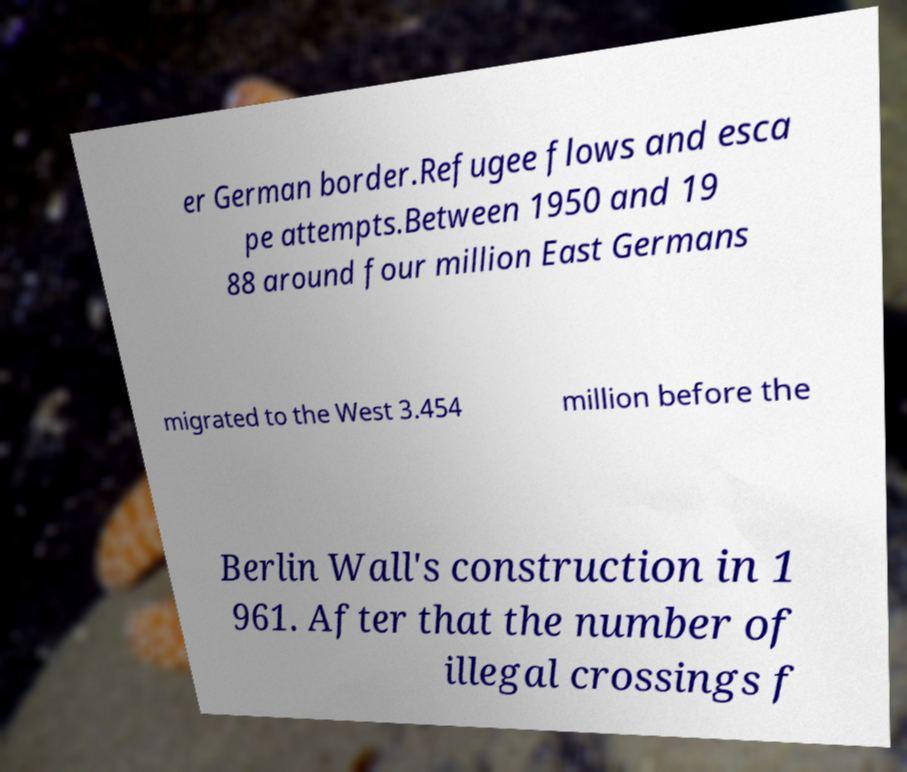Please identify and transcribe the text found in this image. er German border.Refugee flows and esca pe attempts.Between 1950 and 19 88 around four million East Germans migrated to the West 3.454 million before the Berlin Wall's construction in 1 961. After that the number of illegal crossings f 